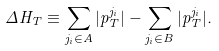Convert formula to latex. <formula><loc_0><loc_0><loc_500><loc_500>\Delta H _ { T } \equiv \sum _ { j _ { i } \in A } | { p } _ { T } ^ { j _ { i } } | - \sum _ { j _ { i } \in B } | { p } _ { T } ^ { j _ { i } } | .</formula> 